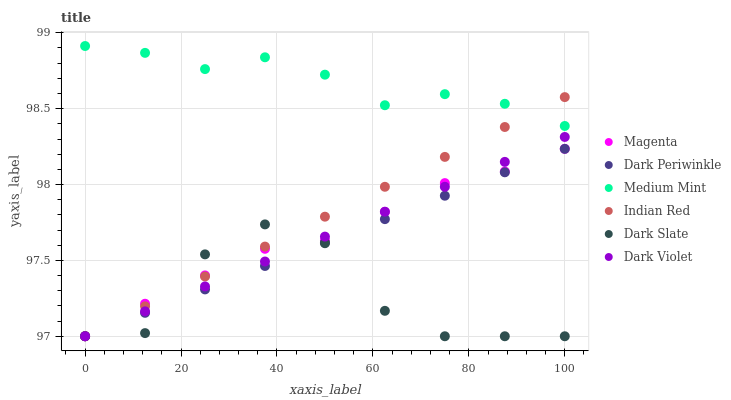Does Dark Slate have the minimum area under the curve?
Answer yes or no. Yes. Does Medium Mint have the maximum area under the curve?
Answer yes or no. Yes. Does Dark Violet have the minimum area under the curve?
Answer yes or no. No. Does Dark Violet have the maximum area under the curve?
Answer yes or no. No. Is Dark Periwinkle the smoothest?
Answer yes or no. Yes. Is Dark Slate the roughest?
Answer yes or no. Yes. Is Dark Violet the smoothest?
Answer yes or no. No. Is Dark Violet the roughest?
Answer yes or no. No. Does Dark Violet have the lowest value?
Answer yes or no. Yes. Does Medium Mint have the highest value?
Answer yes or no. Yes. Does Dark Violet have the highest value?
Answer yes or no. No. Is Magenta less than Medium Mint?
Answer yes or no. Yes. Is Medium Mint greater than Dark Slate?
Answer yes or no. Yes. Does Dark Periwinkle intersect Magenta?
Answer yes or no. Yes. Is Dark Periwinkle less than Magenta?
Answer yes or no. No. Is Dark Periwinkle greater than Magenta?
Answer yes or no. No. Does Magenta intersect Medium Mint?
Answer yes or no. No. 